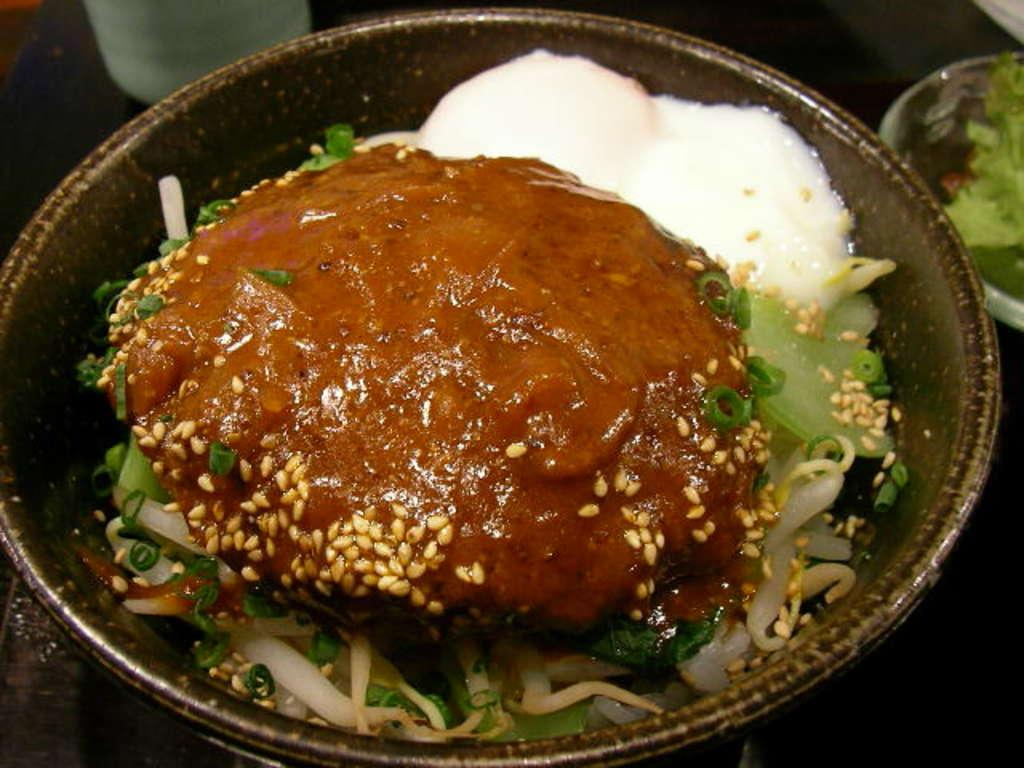What is in the bowl that is visible in the image? There is food in a bowl in the image. What is on the right side of the image? There is food in a plate on the right side of the image. Can you describe anything visible in the background of the image? There is a bottle visible in the background of the image. Is there a squirrel joining the food on the plate in the image? No, there is no squirrel present in the image. How many fingers can be seen interacting with the food in the image? There is no indication of fingers or any human presence in the image. 